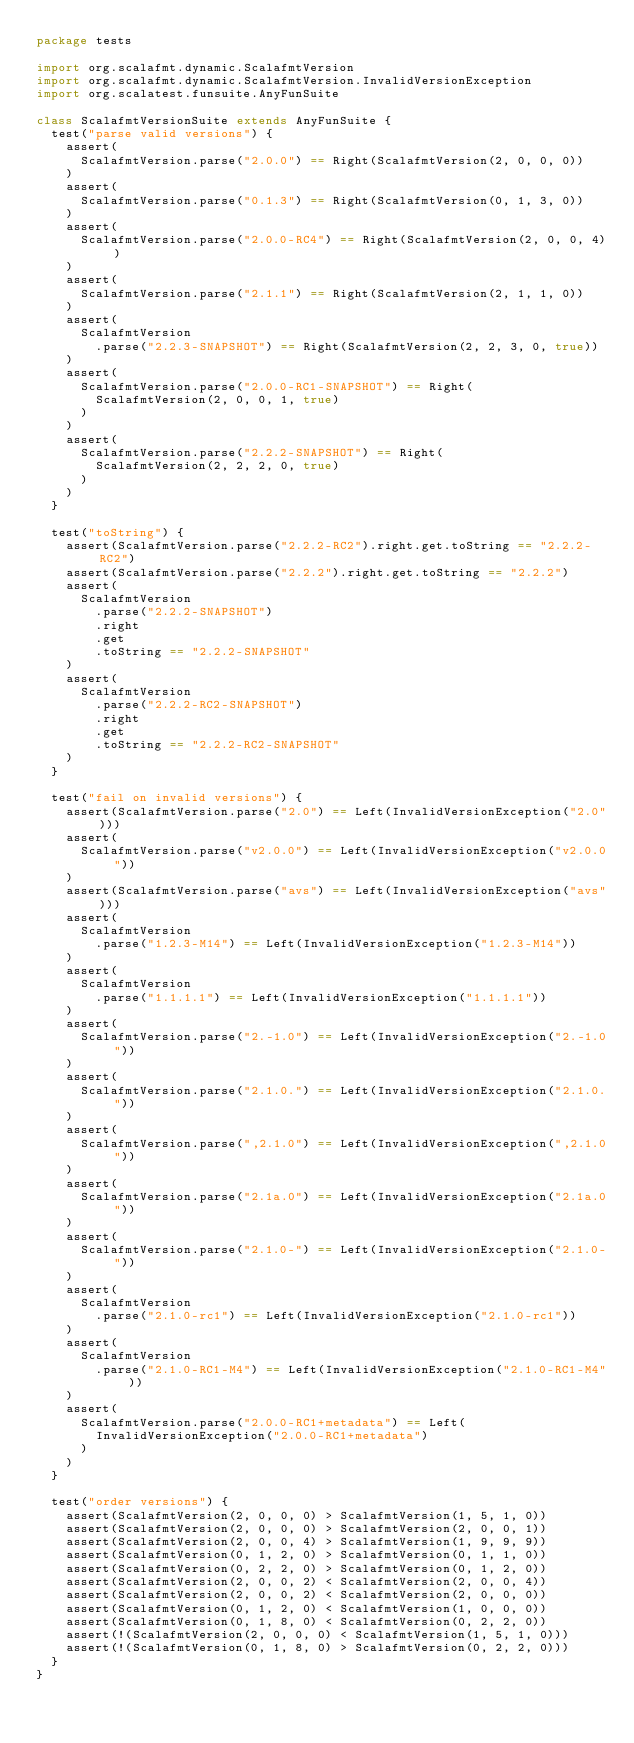<code> <loc_0><loc_0><loc_500><loc_500><_Scala_>package tests

import org.scalafmt.dynamic.ScalafmtVersion
import org.scalafmt.dynamic.ScalafmtVersion.InvalidVersionException
import org.scalatest.funsuite.AnyFunSuite

class ScalafmtVersionSuite extends AnyFunSuite {
  test("parse valid versions") {
    assert(
      ScalafmtVersion.parse("2.0.0") == Right(ScalafmtVersion(2, 0, 0, 0))
    )
    assert(
      ScalafmtVersion.parse("0.1.3") == Right(ScalafmtVersion(0, 1, 3, 0))
    )
    assert(
      ScalafmtVersion.parse("2.0.0-RC4") == Right(ScalafmtVersion(2, 0, 0, 4))
    )
    assert(
      ScalafmtVersion.parse("2.1.1") == Right(ScalafmtVersion(2, 1, 1, 0))
    )
    assert(
      ScalafmtVersion
        .parse("2.2.3-SNAPSHOT") == Right(ScalafmtVersion(2, 2, 3, 0, true))
    )
    assert(
      ScalafmtVersion.parse("2.0.0-RC1-SNAPSHOT") == Right(
        ScalafmtVersion(2, 0, 0, 1, true)
      )
    )
    assert(
      ScalafmtVersion.parse("2.2.2-SNAPSHOT") == Right(
        ScalafmtVersion(2, 2, 2, 0, true)
      )
    )
  }

  test("toString") {
    assert(ScalafmtVersion.parse("2.2.2-RC2").right.get.toString == "2.2.2-RC2")
    assert(ScalafmtVersion.parse("2.2.2").right.get.toString == "2.2.2")
    assert(
      ScalafmtVersion
        .parse("2.2.2-SNAPSHOT")
        .right
        .get
        .toString == "2.2.2-SNAPSHOT"
    )
    assert(
      ScalafmtVersion
        .parse("2.2.2-RC2-SNAPSHOT")
        .right
        .get
        .toString == "2.2.2-RC2-SNAPSHOT"
    )
  }

  test("fail on invalid versions") {
    assert(ScalafmtVersion.parse("2.0") == Left(InvalidVersionException("2.0")))
    assert(
      ScalafmtVersion.parse("v2.0.0") == Left(InvalidVersionException("v2.0.0"))
    )
    assert(ScalafmtVersion.parse("avs") == Left(InvalidVersionException("avs")))
    assert(
      ScalafmtVersion
        .parse("1.2.3-M14") == Left(InvalidVersionException("1.2.3-M14"))
    )
    assert(
      ScalafmtVersion
        .parse("1.1.1.1") == Left(InvalidVersionException("1.1.1.1"))
    )
    assert(
      ScalafmtVersion.parse("2.-1.0") == Left(InvalidVersionException("2.-1.0"))
    )
    assert(
      ScalafmtVersion.parse("2.1.0.") == Left(InvalidVersionException("2.1.0."))
    )
    assert(
      ScalafmtVersion.parse(",2.1.0") == Left(InvalidVersionException(",2.1.0"))
    )
    assert(
      ScalafmtVersion.parse("2.1a.0") == Left(InvalidVersionException("2.1a.0"))
    )
    assert(
      ScalafmtVersion.parse("2.1.0-") == Left(InvalidVersionException("2.1.0-"))
    )
    assert(
      ScalafmtVersion
        .parse("2.1.0-rc1") == Left(InvalidVersionException("2.1.0-rc1"))
    )
    assert(
      ScalafmtVersion
        .parse("2.1.0-RC1-M4") == Left(InvalidVersionException("2.1.0-RC1-M4"))
    )
    assert(
      ScalafmtVersion.parse("2.0.0-RC1+metadata") == Left(
        InvalidVersionException("2.0.0-RC1+metadata")
      )
    )
  }

  test("order versions") {
    assert(ScalafmtVersion(2, 0, 0, 0) > ScalafmtVersion(1, 5, 1, 0))
    assert(ScalafmtVersion(2, 0, 0, 0) > ScalafmtVersion(2, 0, 0, 1))
    assert(ScalafmtVersion(2, 0, 0, 4) > ScalafmtVersion(1, 9, 9, 9))
    assert(ScalafmtVersion(0, 1, 2, 0) > ScalafmtVersion(0, 1, 1, 0))
    assert(ScalafmtVersion(0, 2, 2, 0) > ScalafmtVersion(0, 1, 2, 0))
    assert(ScalafmtVersion(2, 0, 0, 2) < ScalafmtVersion(2, 0, 0, 4))
    assert(ScalafmtVersion(2, 0, 0, 2) < ScalafmtVersion(2, 0, 0, 0))
    assert(ScalafmtVersion(0, 1, 2, 0) < ScalafmtVersion(1, 0, 0, 0))
    assert(ScalafmtVersion(0, 1, 8, 0) < ScalafmtVersion(0, 2, 2, 0))
    assert(!(ScalafmtVersion(2, 0, 0, 0) < ScalafmtVersion(1, 5, 1, 0)))
    assert(!(ScalafmtVersion(0, 1, 8, 0) > ScalafmtVersion(0, 2, 2, 0)))
  }
}
</code> 